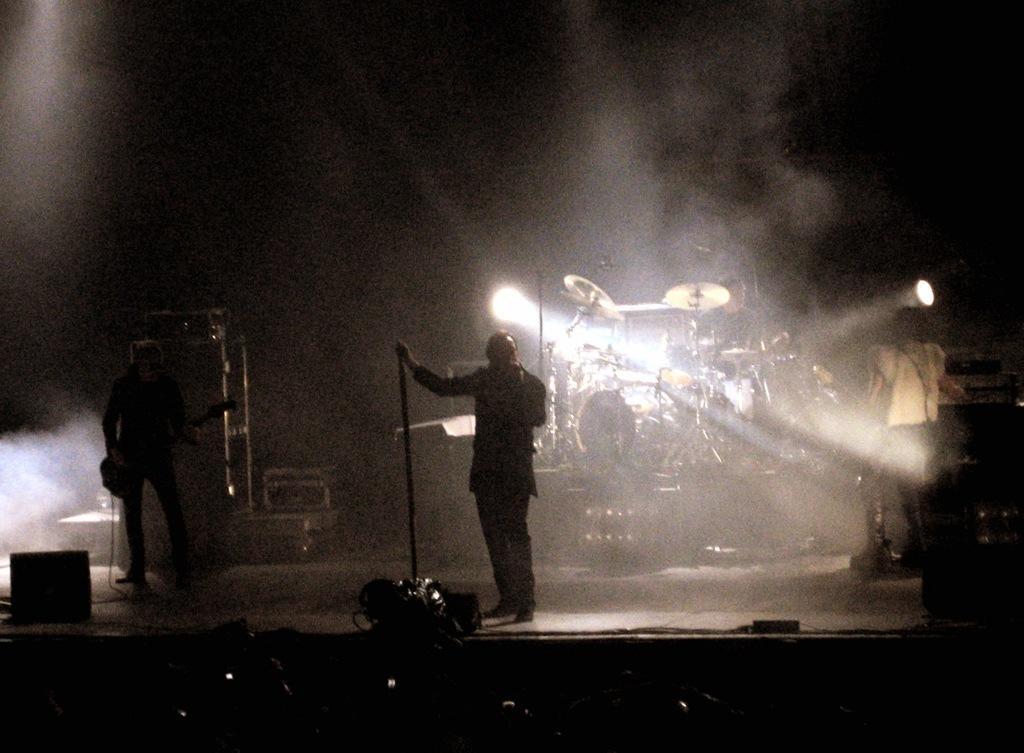How would you summarize this image in a sentence or two? In this image we can see three persons standing on stage. To the left side of the image one person is holding a guitar in his hand. In the center we can see a person holding a stick in his hand. In the background, we can see a group of musical instrument and some lights. 